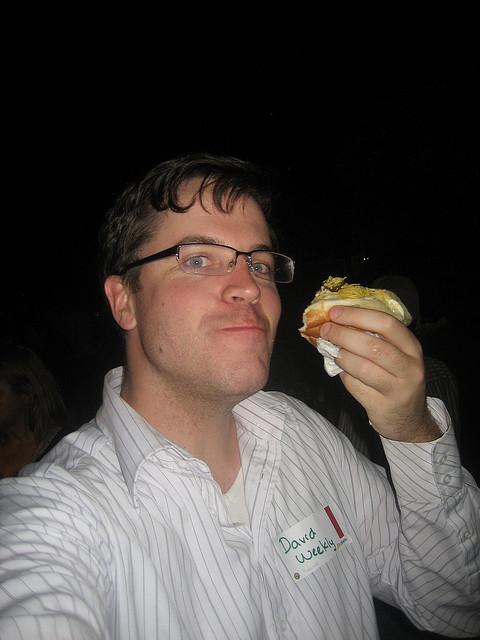What is the condiment on the hotdog?
Concise answer only. Mustard. What is the man holding in the left hand?
Answer briefly. Hot dog. Is it nighttime or daytime?
Be succinct. Nighttime. What is on the person's finger?
Quick response, please. Hot dog. What is the boy wearing?
Answer briefly. Shirt. What are they making?
Answer briefly. Hot dogs. Does this man have lots of hair?
Be succinct. Yes. What are his initials?
Keep it brief. Dw. What is he holding?
Give a very brief answer. Hot dog. What is the man looking at in his hand?
Answer briefly. Sandwich. What is the man doing in the picture?
Give a very brief answer. Eating. What is this person eating?
Keep it brief. Hot dog. Is he wearing  hat?
Keep it brief. No. What is the man eating with?
Short answer required. Hand. Does his shirt have sleeves?
Be succinct. Yes. Is this healthy?
Write a very short answer. No. What is the man wearing on his hands?
Write a very short answer. Nothing. What is he eating?
Give a very brief answer. Hot dog. Is the man wearing nail polish?
Write a very short answer. No. Does the man have facial hair?
Give a very brief answer. No. Is he eating a tuna sandwich?
Concise answer only. No. What is in the man's hand?
Be succinct. Sandwich. What is hanging from his shirt?
Concise answer only. Nametag. Is the sun out?
Write a very short answer. No. Is he wearing a hat?
Write a very short answer. No. What is the man's first name?
Give a very brief answer. David. Are the man's eyes open?
Answer briefly. Yes. What is near the man's ear?
Short answer required. Glasses. Is this food easy to eat?
Quick response, please. Yes. What is the man eating?
Keep it brief. Hot dog. Does this man have long hair?
Keep it brief. No. Is this man married?
Concise answer only. No. Who is being fed?
Short answer required. Man. What meat goes in this bun?
Be succinct. Hot dog. Which hand is the man holding towards the camera?
Be succinct. Right. 